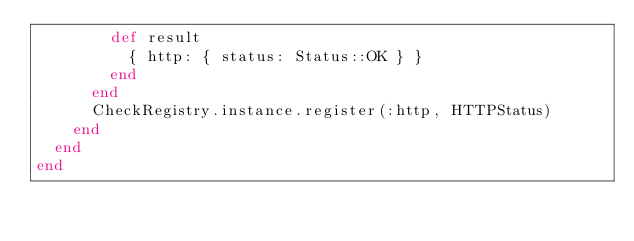Convert code to text. <code><loc_0><loc_0><loc_500><loc_500><_Ruby_>        def result
          { http: { status: Status::OK } }
        end
      end
      CheckRegistry.instance.register(:http, HTTPStatus)
    end
  end
end
</code> 